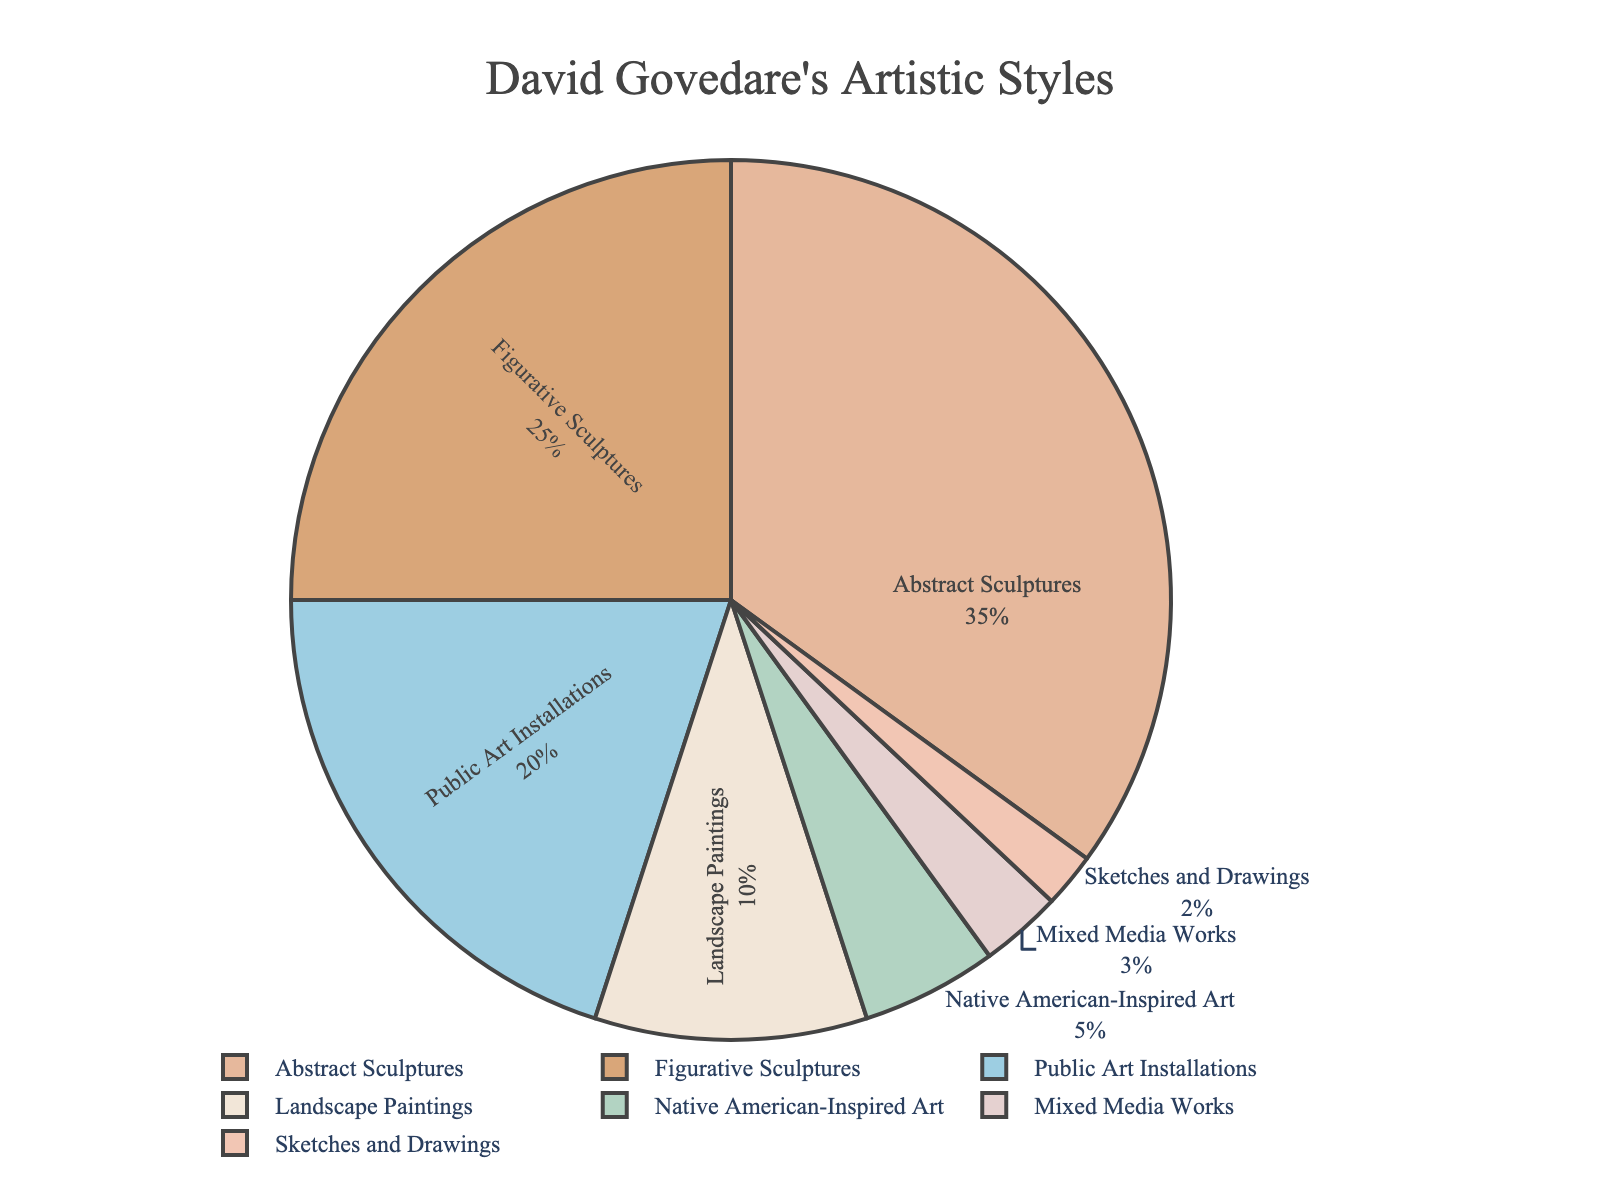what artistic style makes up the largest proportion of Govedare's works? The largest section in the pie chart corresponds to Abstract Sculptures, occupying 35% of the total pie.
Answer: Abstract Sculptures Which two artistic styles combined make up over half of the chart? Abstract Sculptures (35%) and Figurative Sculptures (25%) together make up 60% of the chart, which is more than half of the total.
Answer: Abstract Sculptures and Figurative Sculptures How does the proportion of Public Art Installations compare to that of Landscape Paintings? The proportion of Public Art Installations is 20%, which is double that of Landscape Paintings, which is 10%.
Answer: Public Art Installations is double Landscape Paintings What percentage of Govedare's works falls into styles other than Abstract Sculptures and Figurative Sculptures? The percentage for styles other than Abstract Sculptures (35%) and Figurative Sculptures (25%) is the remaining percentage of the total. Summing up the other styles: 20% + 10% + 5% + 3% + 2% = 40%.
Answer: 40% Which artistic style has the least representation in Govedare's works? The smallest section on the pie chart corresponds to Sketches and Drawings, making up only 2% of the total.
Answer: Sketches and Drawings If we combine Mixed Media Works and Sketches and Drawings, how does their total compare to Native American-Inspired Art? Mixed Media Works and Sketches and Drawings together sum to 3% + 2% = 5%, which is the same percentage as Native American-Inspired Art.
Answer: Equal What's the combined percentage of Public Art Installations, Native American-Inspired Art, and Sketches and Drawings? Summing them up: 20% (Public Art Installations) + 5% (Native American-Inspired Art) + 2% (Sketches and Drawings) = 27%.
Answer: 27% How many artistic styles have a percentage less than 10%? The styles below 10% are Native American-Inspired Art (5%), Mixed Media Works (3%), and Sketches and Drawings (2%). This accounts for three styles.
Answer: 3 